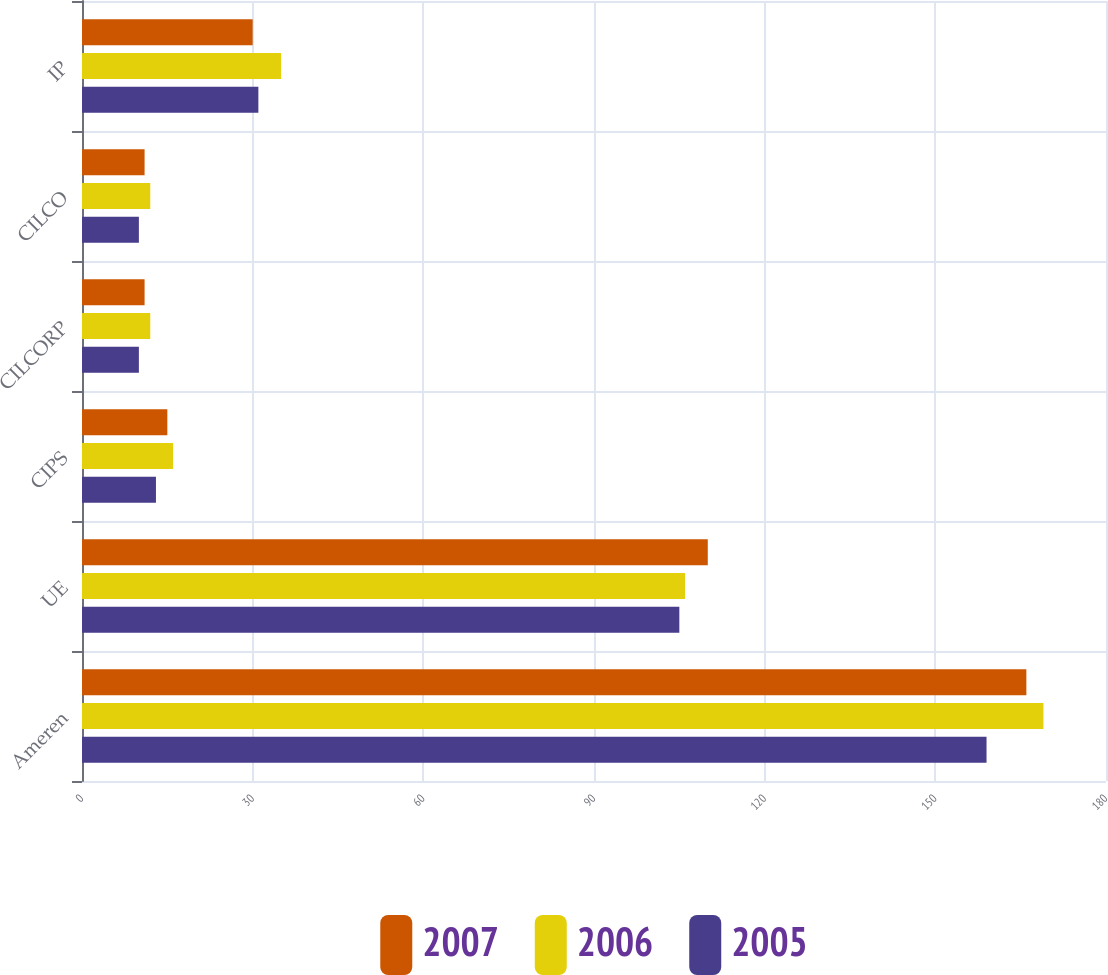Convert chart. <chart><loc_0><loc_0><loc_500><loc_500><stacked_bar_chart><ecel><fcel>Ameren<fcel>UE<fcel>CIPS<fcel>CILCORP<fcel>CILCO<fcel>IP<nl><fcel>2007<fcel>166<fcel>110<fcel>15<fcel>11<fcel>11<fcel>30<nl><fcel>2006<fcel>169<fcel>106<fcel>16<fcel>12<fcel>12<fcel>35<nl><fcel>2005<fcel>159<fcel>105<fcel>13<fcel>10<fcel>10<fcel>31<nl></chart> 